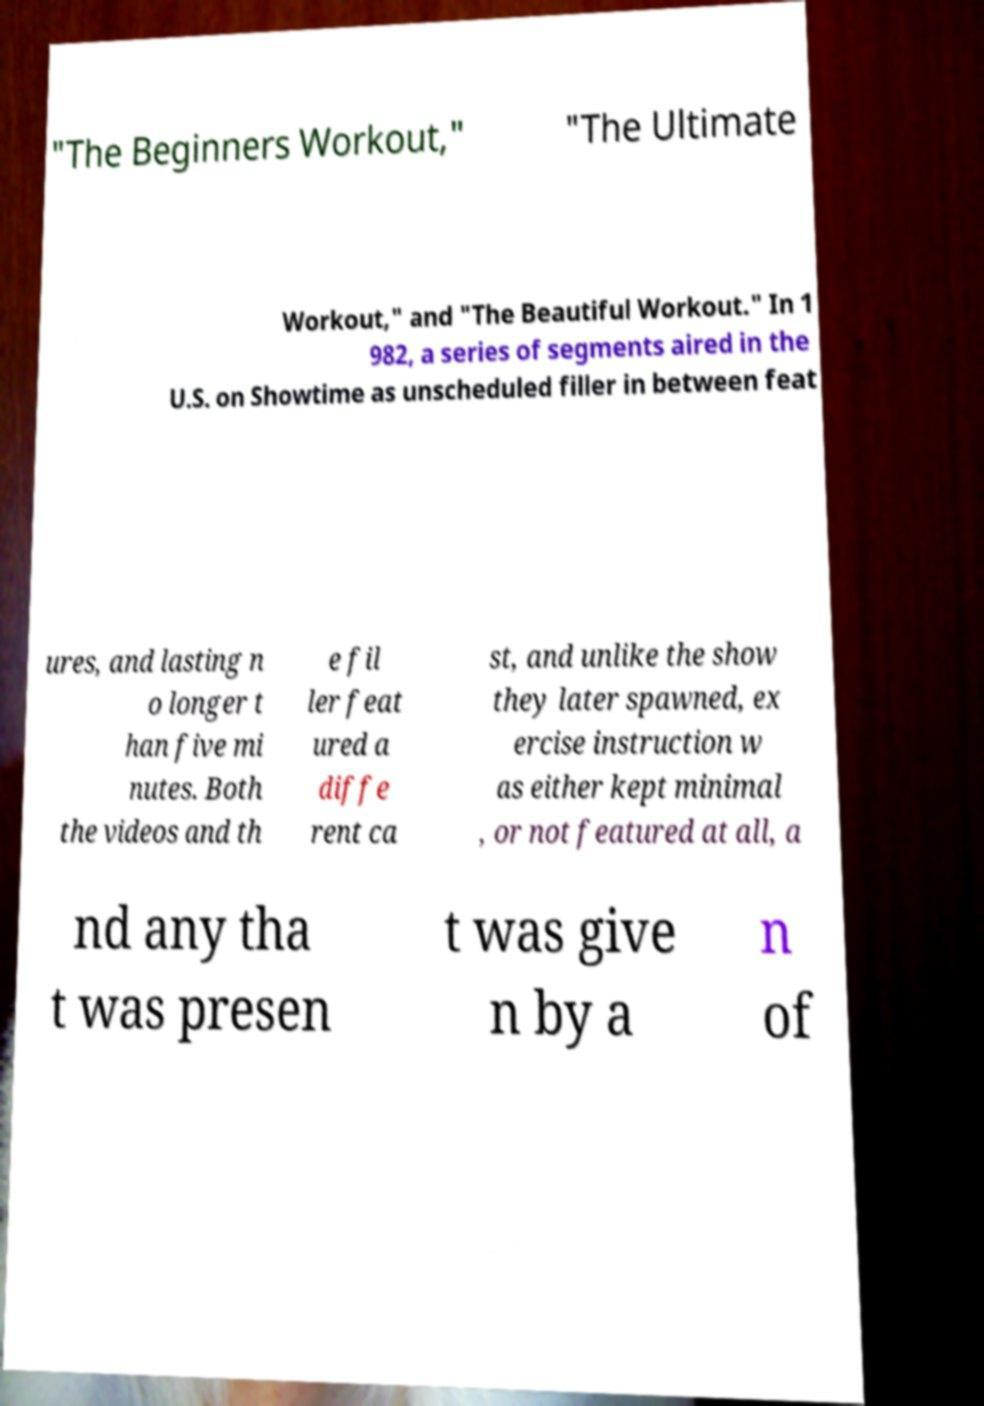I need the written content from this picture converted into text. Can you do that? "The Beginners Workout," "The Ultimate Workout," and "The Beautiful Workout." In 1 982, a series of segments aired in the U.S. on Showtime as unscheduled filler in between feat ures, and lasting n o longer t han five mi nutes. Both the videos and th e fil ler feat ured a diffe rent ca st, and unlike the show they later spawned, ex ercise instruction w as either kept minimal , or not featured at all, a nd any tha t was presen t was give n by a n of 